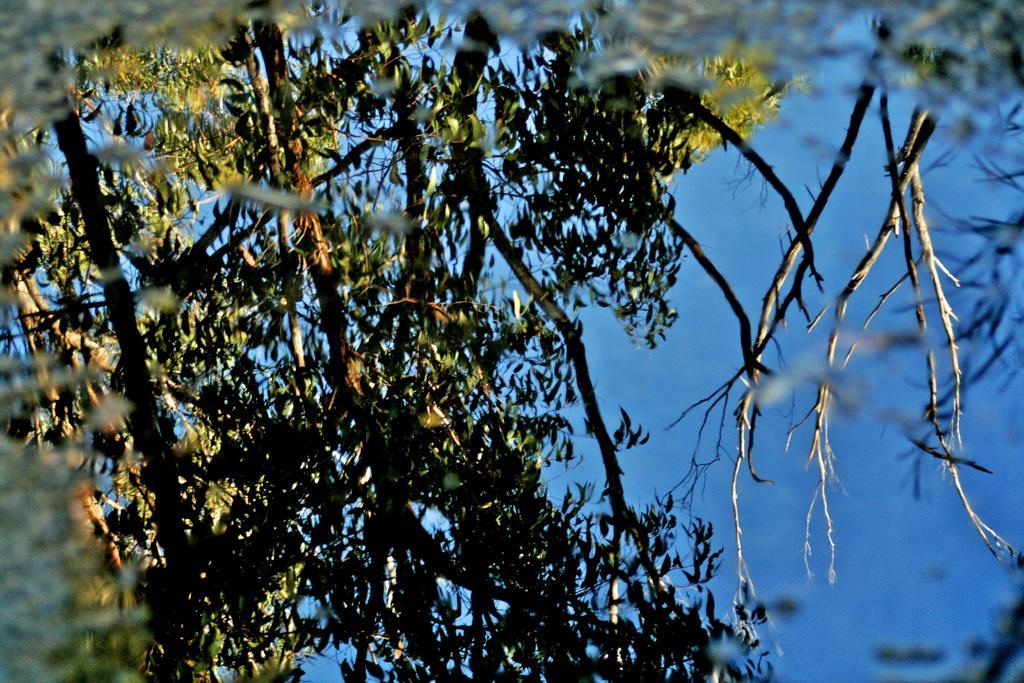Could you give a brief overview of what you see in this image? In this image there is a tree, at the background of the image there is the sky, the background of the image is blue in color. 